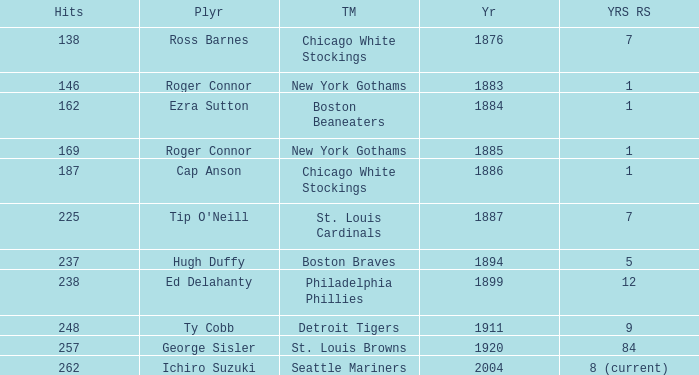Name the least hits for year less than 1920 and player of ed delahanty 238.0. 